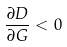Convert formula to latex. <formula><loc_0><loc_0><loc_500><loc_500>\frac { \partial D } { \partial G } < 0</formula> 